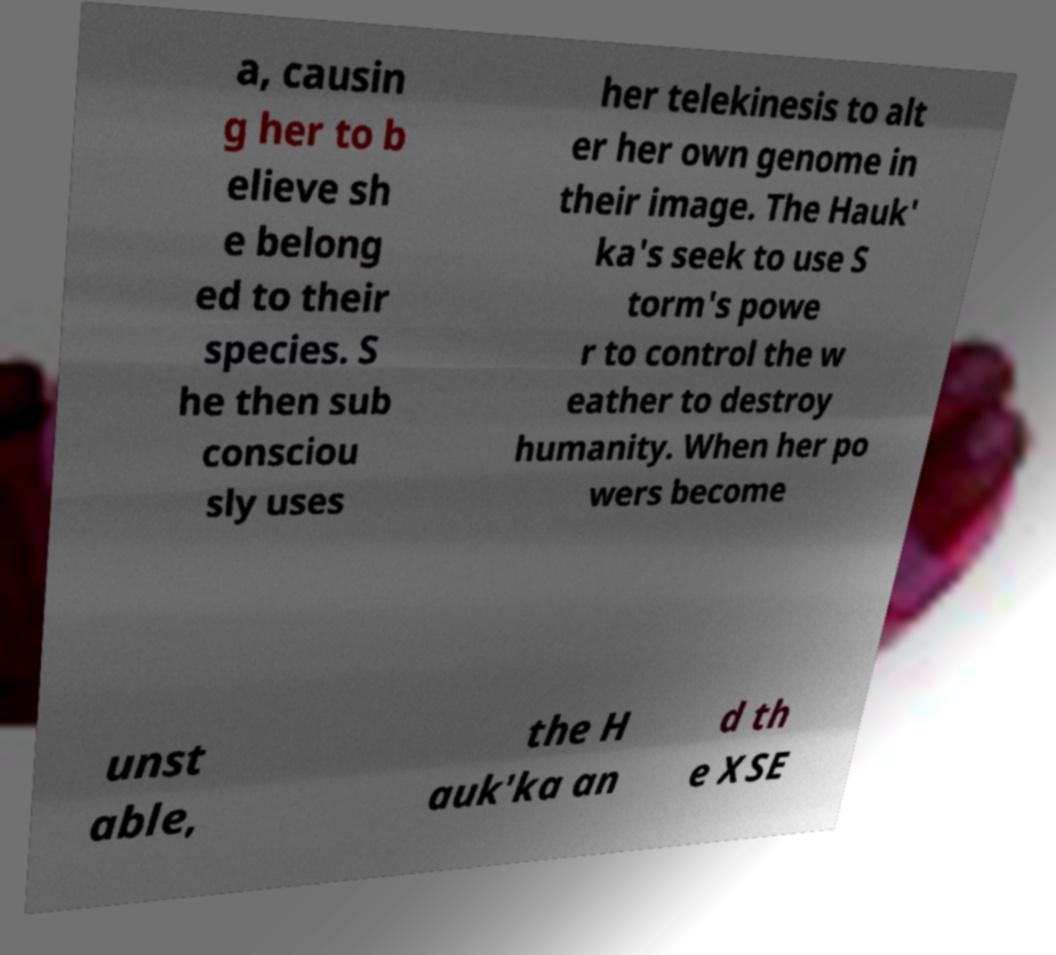Could you extract and type out the text from this image? a, causin g her to b elieve sh e belong ed to their species. S he then sub consciou sly uses her telekinesis to alt er her own genome in their image. The Hauk' ka's seek to use S torm's powe r to control the w eather to destroy humanity. When her po wers become unst able, the H auk'ka an d th e XSE 